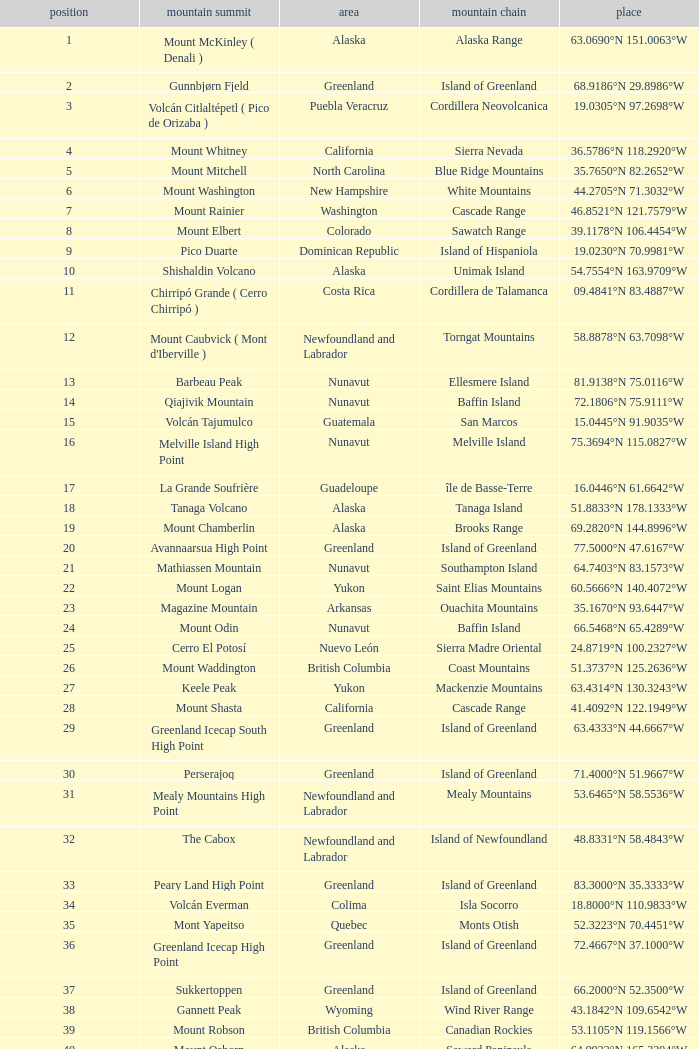Name the Region with a Mountain Peak of dillingham high point? Alaska. 